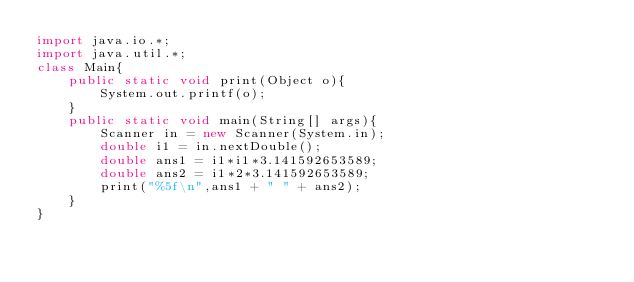Convert code to text. <code><loc_0><loc_0><loc_500><loc_500><_Java_>import java.io.*;
import java.util.*;
class Main{
	public static void print(Object o){
		System.out.printf(o);
	}
	public static void main(String[] args){
		Scanner in = new Scanner(System.in);
		double i1 = in.nextDouble();
		double ans1 = i1*i1*3.141592653589;
		double ans2 = i1*2*3.141592653589;
		print("%5f\n",ans1 + " " + ans2);
	}
}</code> 